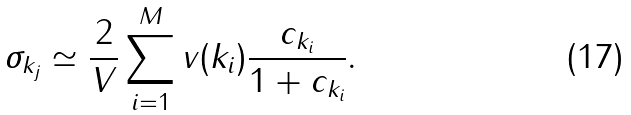Convert formula to latex. <formula><loc_0><loc_0><loc_500><loc_500>\sigma _ { { k } _ { j } } \simeq \frac { 2 } { V } \sum _ { i = 1 } ^ { M } v ( k _ { i } ) \frac { c _ { { k } _ { i } } } { 1 + c _ { { k } _ { i } } } .</formula> 